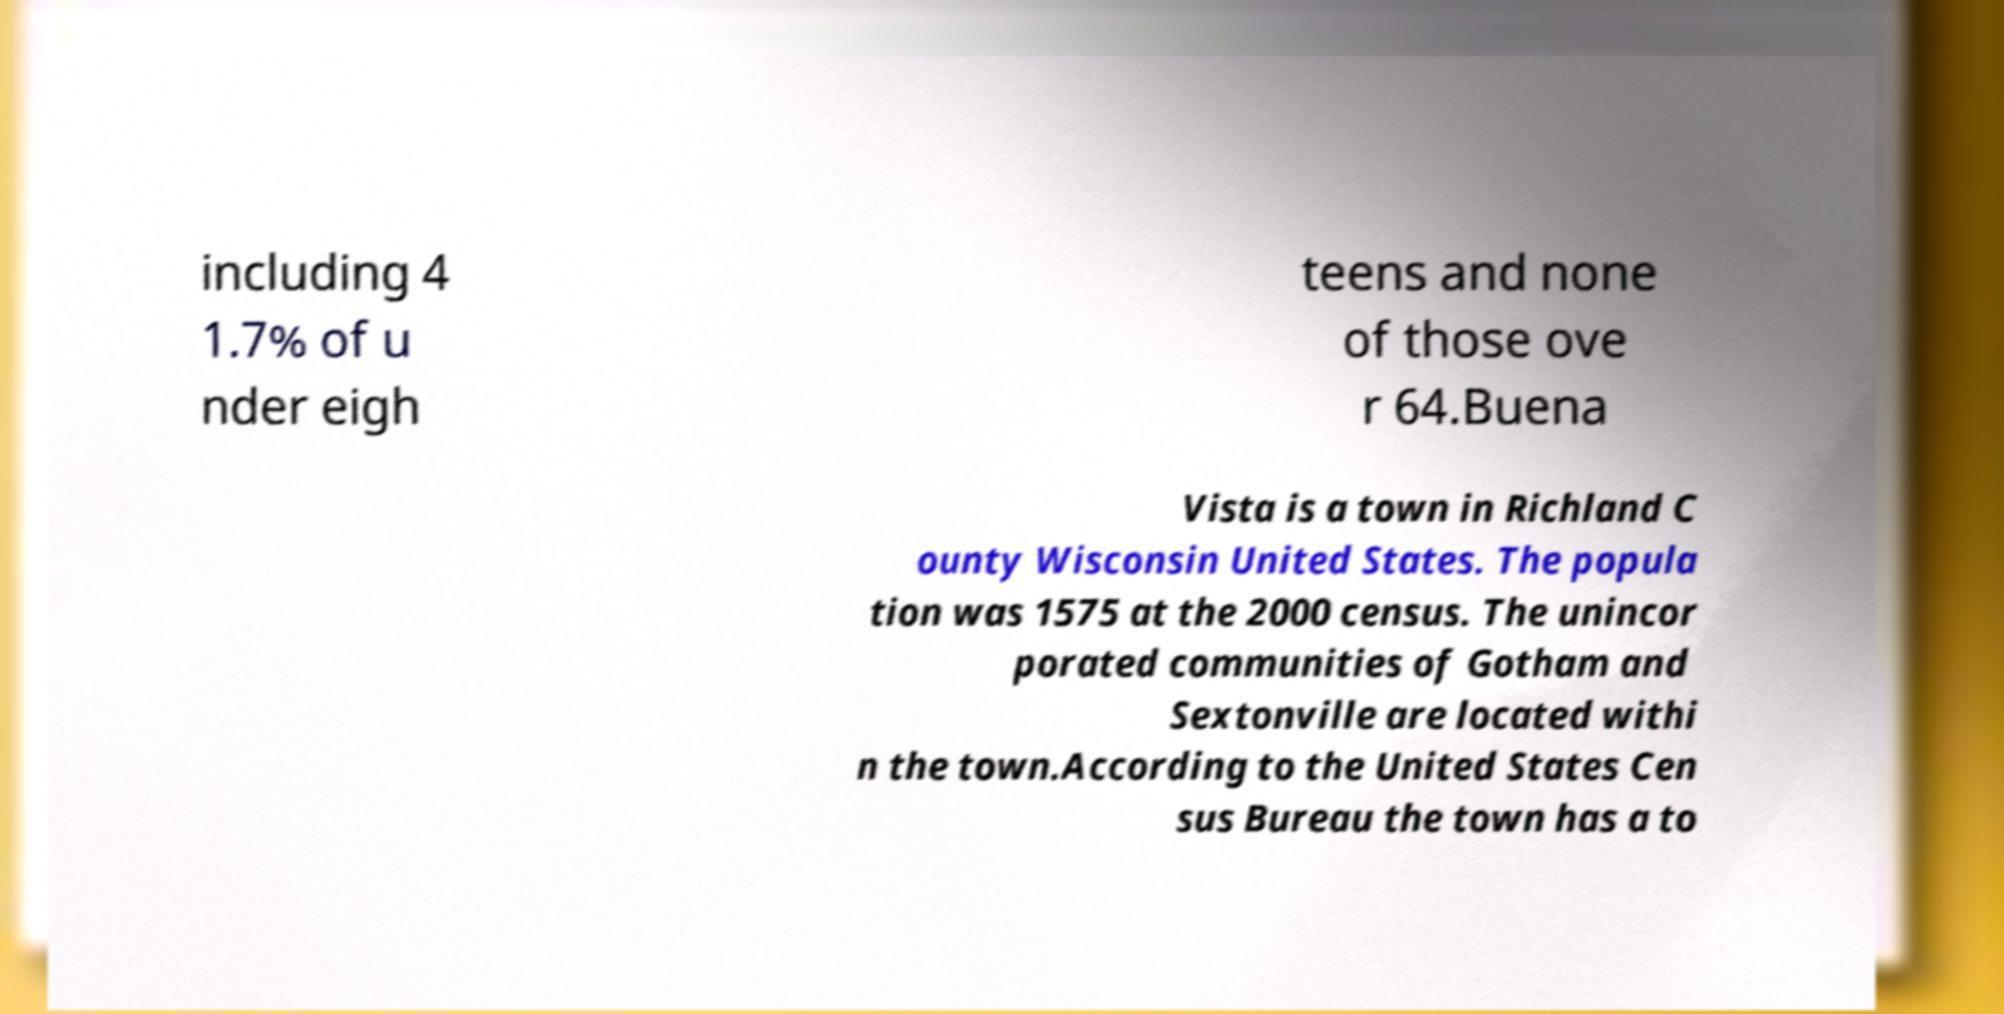Please identify and transcribe the text found in this image. including 4 1.7% of u nder eigh teens and none of those ove r 64.Buena Vista is a town in Richland C ounty Wisconsin United States. The popula tion was 1575 at the 2000 census. The unincor porated communities of Gotham and Sextonville are located withi n the town.According to the United States Cen sus Bureau the town has a to 